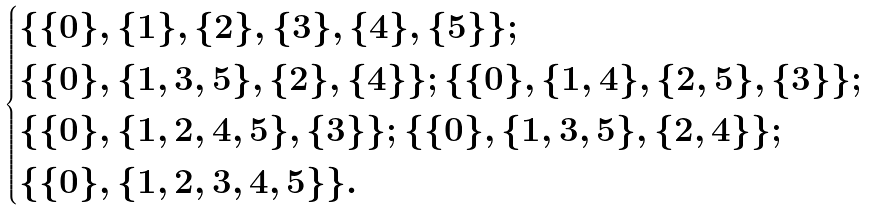Convert formula to latex. <formula><loc_0><loc_0><loc_500><loc_500>\begin{cases} \{ \{ 0 \} , \{ 1 \} , \{ 2 \} , \{ 3 \} , \{ 4 \} , \{ 5 \} \} ; \ \\ \{ \{ 0 \} , \{ 1 , 3 , 5 \} , \{ 2 \} , \{ 4 \} \} ; \{ \{ 0 \} , \{ 1 , 4 \} , \{ 2 , 5 \} , \{ 3 \} \} ; \\ \{ \{ 0 \} , \{ 1 , 2 , 4 , 5 \} , \{ 3 \} \} ; \{ \{ 0 \} , \{ 1 , 3 , 5 \} , \{ 2 , 4 \} \} ; \\ \{ \{ 0 \} , \{ 1 , 2 , 3 , 4 , 5 \} \} . \end{cases}</formula> 